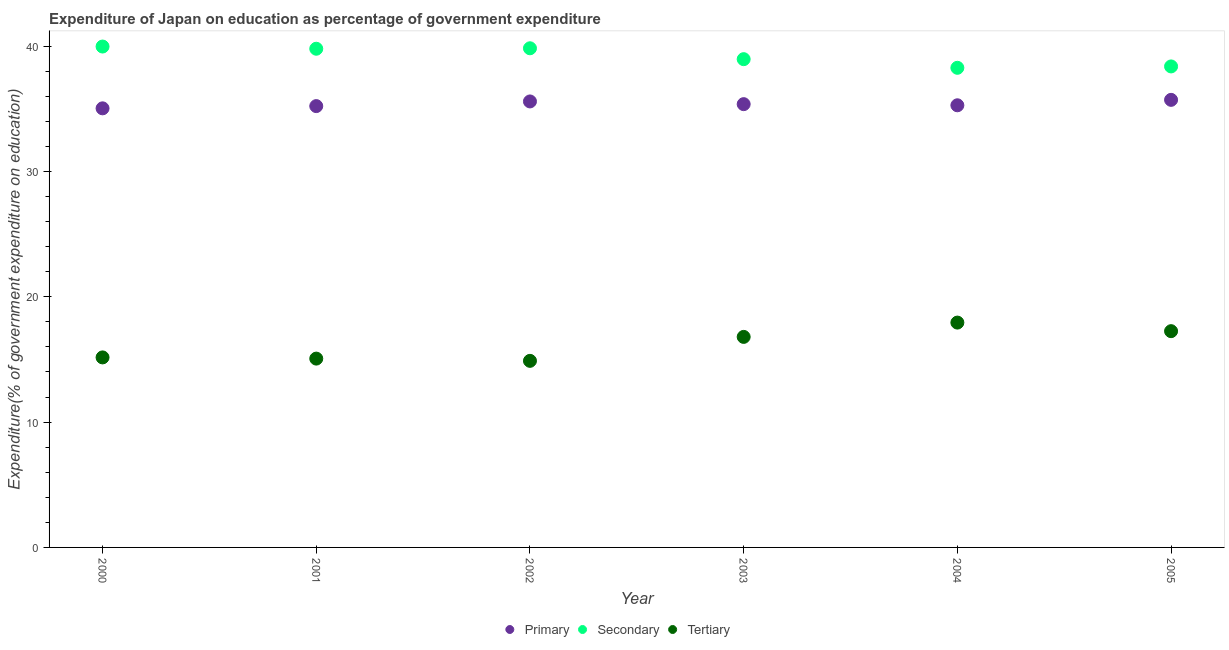What is the expenditure on primary education in 2000?
Ensure brevity in your answer.  35.03. Across all years, what is the maximum expenditure on secondary education?
Your response must be concise. 39.96. Across all years, what is the minimum expenditure on tertiary education?
Provide a short and direct response. 14.88. In which year was the expenditure on tertiary education maximum?
Offer a very short reply. 2004. What is the total expenditure on primary education in the graph?
Make the answer very short. 212.16. What is the difference between the expenditure on primary education in 2000 and that in 2001?
Offer a terse response. -0.18. What is the difference between the expenditure on primary education in 2003 and the expenditure on tertiary education in 2001?
Your answer should be very brief. 20.3. What is the average expenditure on secondary education per year?
Keep it short and to the point. 39.19. In the year 2000, what is the difference between the expenditure on secondary education and expenditure on primary education?
Offer a terse response. 4.93. In how many years, is the expenditure on tertiary education greater than 38 %?
Offer a terse response. 0. What is the ratio of the expenditure on primary education in 2002 to that in 2003?
Make the answer very short. 1.01. Is the expenditure on primary education in 2001 less than that in 2004?
Your answer should be compact. Yes. Is the difference between the expenditure on primary education in 2000 and 2002 greater than the difference between the expenditure on secondary education in 2000 and 2002?
Ensure brevity in your answer.  No. What is the difference between the highest and the second highest expenditure on primary education?
Give a very brief answer. 0.13. What is the difference between the highest and the lowest expenditure on tertiary education?
Provide a short and direct response. 3.05. Is it the case that in every year, the sum of the expenditure on primary education and expenditure on secondary education is greater than the expenditure on tertiary education?
Offer a very short reply. Yes. Does the expenditure on primary education monotonically increase over the years?
Your response must be concise. No. Is the expenditure on primary education strictly greater than the expenditure on secondary education over the years?
Your answer should be very brief. No. How many dotlines are there?
Give a very brief answer. 3. How many years are there in the graph?
Ensure brevity in your answer.  6. Are the values on the major ticks of Y-axis written in scientific E-notation?
Ensure brevity in your answer.  No. Does the graph contain any zero values?
Provide a short and direct response. No. Does the graph contain grids?
Your response must be concise. No. Where does the legend appear in the graph?
Ensure brevity in your answer.  Bottom center. What is the title of the graph?
Give a very brief answer. Expenditure of Japan on education as percentage of government expenditure. Does "Transport services" appear as one of the legend labels in the graph?
Provide a short and direct response. No. What is the label or title of the X-axis?
Provide a succinct answer. Year. What is the label or title of the Y-axis?
Provide a short and direct response. Expenditure(% of government expenditure on education). What is the Expenditure(% of government expenditure on education) in Primary in 2000?
Your response must be concise. 35.03. What is the Expenditure(% of government expenditure on education) in Secondary in 2000?
Make the answer very short. 39.96. What is the Expenditure(% of government expenditure on education) of Tertiary in 2000?
Keep it short and to the point. 15.16. What is the Expenditure(% of government expenditure on education) in Primary in 2001?
Provide a short and direct response. 35.21. What is the Expenditure(% of government expenditure on education) of Secondary in 2001?
Provide a succinct answer. 39.78. What is the Expenditure(% of government expenditure on education) of Tertiary in 2001?
Provide a short and direct response. 15.06. What is the Expenditure(% of government expenditure on education) in Primary in 2002?
Offer a terse response. 35.58. What is the Expenditure(% of government expenditure on education) of Secondary in 2002?
Make the answer very short. 39.82. What is the Expenditure(% of government expenditure on education) in Tertiary in 2002?
Give a very brief answer. 14.88. What is the Expenditure(% of government expenditure on education) of Primary in 2003?
Provide a succinct answer. 35.36. What is the Expenditure(% of government expenditure on education) of Secondary in 2003?
Provide a short and direct response. 38.95. What is the Expenditure(% of government expenditure on education) of Tertiary in 2003?
Offer a terse response. 16.8. What is the Expenditure(% of government expenditure on education) in Primary in 2004?
Ensure brevity in your answer.  35.27. What is the Expenditure(% of government expenditure on education) in Secondary in 2004?
Your answer should be compact. 38.26. What is the Expenditure(% of government expenditure on education) of Tertiary in 2004?
Offer a very short reply. 17.94. What is the Expenditure(% of government expenditure on education) in Primary in 2005?
Ensure brevity in your answer.  35.71. What is the Expenditure(% of government expenditure on education) in Secondary in 2005?
Provide a succinct answer. 38.37. What is the Expenditure(% of government expenditure on education) in Tertiary in 2005?
Provide a succinct answer. 17.25. Across all years, what is the maximum Expenditure(% of government expenditure on education) in Primary?
Your response must be concise. 35.71. Across all years, what is the maximum Expenditure(% of government expenditure on education) of Secondary?
Your response must be concise. 39.96. Across all years, what is the maximum Expenditure(% of government expenditure on education) in Tertiary?
Your answer should be very brief. 17.94. Across all years, what is the minimum Expenditure(% of government expenditure on education) in Primary?
Offer a terse response. 35.03. Across all years, what is the minimum Expenditure(% of government expenditure on education) in Secondary?
Give a very brief answer. 38.26. Across all years, what is the minimum Expenditure(% of government expenditure on education) of Tertiary?
Keep it short and to the point. 14.88. What is the total Expenditure(% of government expenditure on education) of Primary in the graph?
Offer a terse response. 212.16. What is the total Expenditure(% of government expenditure on education) in Secondary in the graph?
Provide a succinct answer. 235.15. What is the total Expenditure(% of government expenditure on education) of Tertiary in the graph?
Provide a short and direct response. 97.09. What is the difference between the Expenditure(% of government expenditure on education) in Primary in 2000 and that in 2001?
Your response must be concise. -0.18. What is the difference between the Expenditure(% of government expenditure on education) in Secondary in 2000 and that in 2001?
Provide a short and direct response. 0.18. What is the difference between the Expenditure(% of government expenditure on education) of Tertiary in 2000 and that in 2001?
Make the answer very short. 0.1. What is the difference between the Expenditure(% of government expenditure on education) of Primary in 2000 and that in 2002?
Provide a short and direct response. -0.55. What is the difference between the Expenditure(% of government expenditure on education) in Secondary in 2000 and that in 2002?
Your response must be concise. 0.14. What is the difference between the Expenditure(% of government expenditure on education) of Tertiary in 2000 and that in 2002?
Offer a very short reply. 0.27. What is the difference between the Expenditure(% of government expenditure on education) in Primary in 2000 and that in 2003?
Your answer should be very brief. -0.33. What is the difference between the Expenditure(% of government expenditure on education) in Tertiary in 2000 and that in 2003?
Offer a terse response. -1.64. What is the difference between the Expenditure(% of government expenditure on education) in Primary in 2000 and that in 2004?
Give a very brief answer. -0.24. What is the difference between the Expenditure(% of government expenditure on education) in Secondary in 2000 and that in 2004?
Your response must be concise. 1.7. What is the difference between the Expenditure(% of government expenditure on education) in Tertiary in 2000 and that in 2004?
Provide a succinct answer. -2.78. What is the difference between the Expenditure(% of government expenditure on education) in Primary in 2000 and that in 2005?
Provide a short and direct response. -0.68. What is the difference between the Expenditure(% of government expenditure on education) of Secondary in 2000 and that in 2005?
Offer a very short reply. 1.59. What is the difference between the Expenditure(% of government expenditure on education) in Tertiary in 2000 and that in 2005?
Offer a very short reply. -2.09. What is the difference between the Expenditure(% of government expenditure on education) in Primary in 2001 and that in 2002?
Give a very brief answer. -0.37. What is the difference between the Expenditure(% of government expenditure on education) of Secondary in 2001 and that in 2002?
Offer a very short reply. -0.04. What is the difference between the Expenditure(% of government expenditure on education) of Tertiary in 2001 and that in 2002?
Your answer should be very brief. 0.18. What is the difference between the Expenditure(% of government expenditure on education) of Primary in 2001 and that in 2003?
Your response must be concise. -0.16. What is the difference between the Expenditure(% of government expenditure on education) in Secondary in 2001 and that in 2003?
Offer a terse response. 0.83. What is the difference between the Expenditure(% of government expenditure on education) in Tertiary in 2001 and that in 2003?
Offer a terse response. -1.73. What is the difference between the Expenditure(% of government expenditure on education) in Primary in 2001 and that in 2004?
Ensure brevity in your answer.  -0.07. What is the difference between the Expenditure(% of government expenditure on education) of Secondary in 2001 and that in 2004?
Your answer should be compact. 1.52. What is the difference between the Expenditure(% of government expenditure on education) of Tertiary in 2001 and that in 2004?
Keep it short and to the point. -2.87. What is the difference between the Expenditure(% of government expenditure on education) of Primary in 2001 and that in 2005?
Your response must be concise. -0.5. What is the difference between the Expenditure(% of government expenditure on education) in Secondary in 2001 and that in 2005?
Offer a very short reply. 1.41. What is the difference between the Expenditure(% of government expenditure on education) of Tertiary in 2001 and that in 2005?
Ensure brevity in your answer.  -2.19. What is the difference between the Expenditure(% of government expenditure on education) of Primary in 2002 and that in 2003?
Ensure brevity in your answer.  0.22. What is the difference between the Expenditure(% of government expenditure on education) of Secondary in 2002 and that in 2003?
Offer a terse response. 0.87. What is the difference between the Expenditure(% of government expenditure on education) of Tertiary in 2002 and that in 2003?
Provide a succinct answer. -1.91. What is the difference between the Expenditure(% of government expenditure on education) in Primary in 2002 and that in 2004?
Ensure brevity in your answer.  0.31. What is the difference between the Expenditure(% of government expenditure on education) of Secondary in 2002 and that in 2004?
Your answer should be compact. 1.56. What is the difference between the Expenditure(% of government expenditure on education) in Tertiary in 2002 and that in 2004?
Make the answer very short. -3.05. What is the difference between the Expenditure(% of government expenditure on education) in Primary in 2002 and that in 2005?
Your answer should be compact. -0.13. What is the difference between the Expenditure(% of government expenditure on education) of Secondary in 2002 and that in 2005?
Offer a terse response. 1.45. What is the difference between the Expenditure(% of government expenditure on education) in Tertiary in 2002 and that in 2005?
Ensure brevity in your answer.  -2.37. What is the difference between the Expenditure(% of government expenditure on education) of Primary in 2003 and that in 2004?
Your response must be concise. 0.09. What is the difference between the Expenditure(% of government expenditure on education) of Secondary in 2003 and that in 2004?
Provide a short and direct response. 0.69. What is the difference between the Expenditure(% of government expenditure on education) of Tertiary in 2003 and that in 2004?
Offer a terse response. -1.14. What is the difference between the Expenditure(% of government expenditure on education) of Primary in 2003 and that in 2005?
Offer a very short reply. -0.34. What is the difference between the Expenditure(% of government expenditure on education) of Secondary in 2003 and that in 2005?
Your response must be concise. 0.58. What is the difference between the Expenditure(% of government expenditure on education) of Tertiary in 2003 and that in 2005?
Your answer should be very brief. -0.46. What is the difference between the Expenditure(% of government expenditure on education) of Primary in 2004 and that in 2005?
Offer a terse response. -0.43. What is the difference between the Expenditure(% of government expenditure on education) in Secondary in 2004 and that in 2005?
Provide a short and direct response. -0.11. What is the difference between the Expenditure(% of government expenditure on education) in Tertiary in 2004 and that in 2005?
Provide a succinct answer. 0.68. What is the difference between the Expenditure(% of government expenditure on education) of Primary in 2000 and the Expenditure(% of government expenditure on education) of Secondary in 2001?
Ensure brevity in your answer.  -4.75. What is the difference between the Expenditure(% of government expenditure on education) of Primary in 2000 and the Expenditure(% of government expenditure on education) of Tertiary in 2001?
Your response must be concise. 19.97. What is the difference between the Expenditure(% of government expenditure on education) in Secondary in 2000 and the Expenditure(% of government expenditure on education) in Tertiary in 2001?
Your answer should be compact. 24.9. What is the difference between the Expenditure(% of government expenditure on education) of Primary in 2000 and the Expenditure(% of government expenditure on education) of Secondary in 2002?
Provide a succinct answer. -4.79. What is the difference between the Expenditure(% of government expenditure on education) in Primary in 2000 and the Expenditure(% of government expenditure on education) in Tertiary in 2002?
Make the answer very short. 20.14. What is the difference between the Expenditure(% of government expenditure on education) of Secondary in 2000 and the Expenditure(% of government expenditure on education) of Tertiary in 2002?
Ensure brevity in your answer.  25.07. What is the difference between the Expenditure(% of government expenditure on education) of Primary in 2000 and the Expenditure(% of government expenditure on education) of Secondary in 2003?
Provide a short and direct response. -3.92. What is the difference between the Expenditure(% of government expenditure on education) in Primary in 2000 and the Expenditure(% of government expenditure on education) in Tertiary in 2003?
Provide a succinct answer. 18.23. What is the difference between the Expenditure(% of government expenditure on education) of Secondary in 2000 and the Expenditure(% of government expenditure on education) of Tertiary in 2003?
Give a very brief answer. 23.16. What is the difference between the Expenditure(% of government expenditure on education) in Primary in 2000 and the Expenditure(% of government expenditure on education) in Secondary in 2004?
Provide a succinct answer. -3.23. What is the difference between the Expenditure(% of government expenditure on education) of Primary in 2000 and the Expenditure(% of government expenditure on education) of Tertiary in 2004?
Offer a very short reply. 17.09. What is the difference between the Expenditure(% of government expenditure on education) of Secondary in 2000 and the Expenditure(% of government expenditure on education) of Tertiary in 2004?
Provide a succinct answer. 22.02. What is the difference between the Expenditure(% of government expenditure on education) in Primary in 2000 and the Expenditure(% of government expenditure on education) in Secondary in 2005?
Your answer should be very brief. -3.34. What is the difference between the Expenditure(% of government expenditure on education) of Primary in 2000 and the Expenditure(% of government expenditure on education) of Tertiary in 2005?
Offer a very short reply. 17.78. What is the difference between the Expenditure(% of government expenditure on education) of Secondary in 2000 and the Expenditure(% of government expenditure on education) of Tertiary in 2005?
Keep it short and to the point. 22.71. What is the difference between the Expenditure(% of government expenditure on education) in Primary in 2001 and the Expenditure(% of government expenditure on education) in Secondary in 2002?
Your answer should be compact. -4.61. What is the difference between the Expenditure(% of government expenditure on education) in Primary in 2001 and the Expenditure(% of government expenditure on education) in Tertiary in 2002?
Give a very brief answer. 20.32. What is the difference between the Expenditure(% of government expenditure on education) of Secondary in 2001 and the Expenditure(% of government expenditure on education) of Tertiary in 2002?
Provide a short and direct response. 24.9. What is the difference between the Expenditure(% of government expenditure on education) in Primary in 2001 and the Expenditure(% of government expenditure on education) in Secondary in 2003?
Give a very brief answer. -3.74. What is the difference between the Expenditure(% of government expenditure on education) of Primary in 2001 and the Expenditure(% of government expenditure on education) of Tertiary in 2003?
Keep it short and to the point. 18.41. What is the difference between the Expenditure(% of government expenditure on education) in Secondary in 2001 and the Expenditure(% of government expenditure on education) in Tertiary in 2003?
Make the answer very short. 22.99. What is the difference between the Expenditure(% of government expenditure on education) in Primary in 2001 and the Expenditure(% of government expenditure on education) in Secondary in 2004?
Your answer should be compact. -3.05. What is the difference between the Expenditure(% of government expenditure on education) in Primary in 2001 and the Expenditure(% of government expenditure on education) in Tertiary in 2004?
Offer a very short reply. 17.27. What is the difference between the Expenditure(% of government expenditure on education) of Secondary in 2001 and the Expenditure(% of government expenditure on education) of Tertiary in 2004?
Your response must be concise. 21.85. What is the difference between the Expenditure(% of government expenditure on education) in Primary in 2001 and the Expenditure(% of government expenditure on education) in Secondary in 2005?
Offer a terse response. -3.16. What is the difference between the Expenditure(% of government expenditure on education) in Primary in 2001 and the Expenditure(% of government expenditure on education) in Tertiary in 2005?
Provide a short and direct response. 17.96. What is the difference between the Expenditure(% of government expenditure on education) of Secondary in 2001 and the Expenditure(% of government expenditure on education) of Tertiary in 2005?
Offer a very short reply. 22.53. What is the difference between the Expenditure(% of government expenditure on education) in Primary in 2002 and the Expenditure(% of government expenditure on education) in Secondary in 2003?
Keep it short and to the point. -3.37. What is the difference between the Expenditure(% of government expenditure on education) in Primary in 2002 and the Expenditure(% of government expenditure on education) in Tertiary in 2003?
Provide a short and direct response. 18.78. What is the difference between the Expenditure(% of government expenditure on education) of Secondary in 2002 and the Expenditure(% of government expenditure on education) of Tertiary in 2003?
Your answer should be very brief. 23.03. What is the difference between the Expenditure(% of government expenditure on education) in Primary in 2002 and the Expenditure(% of government expenditure on education) in Secondary in 2004?
Your answer should be very brief. -2.68. What is the difference between the Expenditure(% of government expenditure on education) in Primary in 2002 and the Expenditure(% of government expenditure on education) in Tertiary in 2004?
Provide a short and direct response. 17.64. What is the difference between the Expenditure(% of government expenditure on education) of Secondary in 2002 and the Expenditure(% of government expenditure on education) of Tertiary in 2004?
Your answer should be compact. 21.88. What is the difference between the Expenditure(% of government expenditure on education) in Primary in 2002 and the Expenditure(% of government expenditure on education) in Secondary in 2005?
Make the answer very short. -2.79. What is the difference between the Expenditure(% of government expenditure on education) in Primary in 2002 and the Expenditure(% of government expenditure on education) in Tertiary in 2005?
Your answer should be very brief. 18.33. What is the difference between the Expenditure(% of government expenditure on education) of Secondary in 2002 and the Expenditure(% of government expenditure on education) of Tertiary in 2005?
Your response must be concise. 22.57. What is the difference between the Expenditure(% of government expenditure on education) of Primary in 2003 and the Expenditure(% of government expenditure on education) of Secondary in 2004?
Make the answer very short. -2.9. What is the difference between the Expenditure(% of government expenditure on education) in Primary in 2003 and the Expenditure(% of government expenditure on education) in Tertiary in 2004?
Your answer should be very brief. 17.43. What is the difference between the Expenditure(% of government expenditure on education) of Secondary in 2003 and the Expenditure(% of government expenditure on education) of Tertiary in 2004?
Your answer should be compact. 21.02. What is the difference between the Expenditure(% of government expenditure on education) in Primary in 2003 and the Expenditure(% of government expenditure on education) in Secondary in 2005?
Provide a short and direct response. -3.01. What is the difference between the Expenditure(% of government expenditure on education) of Primary in 2003 and the Expenditure(% of government expenditure on education) of Tertiary in 2005?
Provide a short and direct response. 18.11. What is the difference between the Expenditure(% of government expenditure on education) of Secondary in 2003 and the Expenditure(% of government expenditure on education) of Tertiary in 2005?
Your response must be concise. 21.7. What is the difference between the Expenditure(% of government expenditure on education) in Primary in 2004 and the Expenditure(% of government expenditure on education) in Secondary in 2005?
Give a very brief answer. -3.1. What is the difference between the Expenditure(% of government expenditure on education) in Primary in 2004 and the Expenditure(% of government expenditure on education) in Tertiary in 2005?
Your response must be concise. 18.02. What is the difference between the Expenditure(% of government expenditure on education) in Secondary in 2004 and the Expenditure(% of government expenditure on education) in Tertiary in 2005?
Offer a terse response. 21.01. What is the average Expenditure(% of government expenditure on education) in Primary per year?
Your answer should be very brief. 35.36. What is the average Expenditure(% of government expenditure on education) in Secondary per year?
Your answer should be compact. 39.19. What is the average Expenditure(% of government expenditure on education) of Tertiary per year?
Your response must be concise. 16.18. In the year 2000, what is the difference between the Expenditure(% of government expenditure on education) in Primary and Expenditure(% of government expenditure on education) in Secondary?
Your answer should be compact. -4.93. In the year 2000, what is the difference between the Expenditure(% of government expenditure on education) of Primary and Expenditure(% of government expenditure on education) of Tertiary?
Your answer should be very brief. 19.87. In the year 2000, what is the difference between the Expenditure(% of government expenditure on education) of Secondary and Expenditure(% of government expenditure on education) of Tertiary?
Ensure brevity in your answer.  24.8. In the year 2001, what is the difference between the Expenditure(% of government expenditure on education) of Primary and Expenditure(% of government expenditure on education) of Secondary?
Offer a terse response. -4.58. In the year 2001, what is the difference between the Expenditure(% of government expenditure on education) in Primary and Expenditure(% of government expenditure on education) in Tertiary?
Offer a terse response. 20.14. In the year 2001, what is the difference between the Expenditure(% of government expenditure on education) of Secondary and Expenditure(% of government expenditure on education) of Tertiary?
Provide a succinct answer. 24.72. In the year 2002, what is the difference between the Expenditure(% of government expenditure on education) in Primary and Expenditure(% of government expenditure on education) in Secondary?
Your response must be concise. -4.24. In the year 2002, what is the difference between the Expenditure(% of government expenditure on education) of Primary and Expenditure(% of government expenditure on education) of Tertiary?
Offer a very short reply. 20.7. In the year 2002, what is the difference between the Expenditure(% of government expenditure on education) of Secondary and Expenditure(% of government expenditure on education) of Tertiary?
Provide a succinct answer. 24.94. In the year 2003, what is the difference between the Expenditure(% of government expenditure on education) of Primary and Expenditure(% of government expenditure on education) of Secondary?
Make the answer very short. -3.59. In the year 2003, what is the difference between the Expenditure(% of government expenditure on education) in Primary and Expenditure(% of government expenditure on education) in Tertiary?
Give a very brief answer. 18.57. In the year 2003, what is the difference between the Expenditure(% of government expenditure on education) of Secondary and Expenditure(% of government expenditure on education) of Tertiary?
Keep it short and to the point. 22.16. In the year 2004, what is the difference between the Expenditure(% of government expenditure on education) in Primary and Expenditure(% of government expenditure on education) in Secondary?
Your answer should be compact. -2.99. In the year 2004, what is the difference between the Expenditure(% of government expenditure on education) in Primary and Expenditure(% of government expenditure on education) in Tertiary?
Provide a succinct answer. 17.34. In the year 2004, what is the difference between the Expenditure(% of government expenditure on education) of Secondary and Expenditure(% of government expenditure on education) of Tertiary?
Ensure brevity in your answer.  20.33. In the year 2005, what is the difference between the Expenditure(% of government expenditure on education) in Primary and Expenditure(% of government expenditure on education) in Secondary?
Your response must be concise. -2.67. In the year 2005, what is the difference between the Expenditure(% of government expenditure on education) in Primary and Expenditure(% of government expenditure on education) in Tertiary?
Ensure brevity in your answer.  18.45. In the year 2005, what is the difference between the Expenditure(% of government expenditure on education) in Secondary and Expenditure(% of government expenditure on education) in Tertiary?
Offer a very short reply. 21.12. What is the ratio of the Expenditure(% of government expenditure on education) in Tertiary in 2000 to that in 2001?
Your answer should be very brief. 1.01. What is the ratio of the Expenditure(% of government expenditure on education) of Primary in 2000 to that in 2002?
Provide a short and direct response. 0.98. What is the ratio of the Expenditure(% of government expenditure on education) in Secondary in 2000 to that in 2002?
Your response must be concise. 1. What is the ratio of the Expenditure(% of government expenditure on education) in Tertiary in 2000 to that in 2002?
Your response must be concise. 1.02. What is the ratio of the Expenditure(% of government expenditure on education) in Secondary in 2000 to that in 2003?
Provide a succinct answer. 1.03. What is the ratio of the Expenditure(% of government expenditure on education) of Tertiary in 2000 to that in 2003?
Ensure brevity in your answer.  0.9. What is the ratio of the Expenditure(% of government expenditure on education) of Secondary in 2000 to that in 2004?
Keep it short and to the point. 1.04. What is the ratio of the Expenditure(% of government expenditure on education) in Tertiary in 2000 to that in 2004?
Ensure brevity in your answer.  0.85. What is the ratio of the Expenditure(% of government expenditure on education) in Primary in 2000 to that in 2005?
Ensure brevity in your answer.  0.98. What is the ratio of the Expenditure(% of government expenditure on education) of Secondary in 2000 to that in 2005?
Keep it short and to the point. 1.04. What is the ratio of the Expenditure(% of government expenditure on education) of Tertiary in 2000 to that in 2005?
Provide a short and direct response. 0.88. What is the ratio of the Expenditure(% of government expenditure on education) of Primary in 2001 to that in 2002?
Your answer should be very brief. 0.99. What is the ratio of the Expenditure(% of government expenditure on education) of Secondary in 2001 to that in 2002?
Your answer should be very brief. 1. What is the ratio of the Expenditure(% of government expenditure on education) of Tertiary in 2001 to that in 2002?
Provide a short and direct response. 1.01. What is the ratio of the Expenditure(% of government expenditure on education) in Secondary in 2001 to that in 2003?
Provide a short and direct response. 1.02. What is the ratio of the Expenditure(% of government expenditure on education) in Tertiary in 2001 to that in 2003?
Make the answer very short. 0.9. What is the ratio of the Expenditure(% of government expenditure on education) in Primary in 2001 to that in 2004?
Keep it short and to the point. 1. What is the ratio of the Expenditure(% of government expenditure on education) in Secondary in 2001 to that in 2004?
Offer a very short reply. 1.04. What is the ratio of the Expenditure(% of government expenditure on education) in Tertiary in 2001 to that in 2004?
Your response must be concise. 0.84. What is the ratio of the Expenditure(% of government expenditure on education) of Primary in 2001 to that in 2005?
Give a very brief answer. 0.99. What is the ratio of the Expenditure(% of government expenditure on education) of Secondary in 2001 to that in 2005?
Give a very brief answer. 1.04. What is the ratio of the Expenditure(% of government expenditure on education) in Tertiary in 2001 to that in 2005?
Give a very brief answer. 0.87. What is the ratio of the Expenditure(% of government expenditure on education) in Secondary in 2002 to that in 2003?
Your answer should be compact. 1.02. What is the ratio of the Expenditure(% of government expenditure on education) in Tertiary in 2002 to that in 2003?
Your response must be concise. 0.89. What is the ratio of the Expenditure(% of government expenditure on education) of Primary in 2002 to that in 2004?
Keep it short and to the point. 1.01. What is the ratio of the Expenditure(% of government expenditure on education) in Secondary in 2002 to that in 2004?
Offer a terse response. 1.04. What is the ratio of the Expenditure(% of government expenditure on education) of Tertiary in 2002 to that in 2004?
Your answer should be very brief. 0.83. What is the ratio of the Expenditure(% of government expenditure on education) of Secondary in 2002 to that in 2005?
Your response must be concise. 1.04. What is the ratio of the Expenditure(% of government expenditure on education) of Tertiary in 2002 to that in 2005?
Offer a very short reply. 0.86. What is the ratio of the Expenditure(% of government expenditure on education) of Tertiary in 2003 to that in 2004?
Your answer should be very brief. 0.94. What is the ratio of the Expenditure(% of government expenditure on education) of Primary in 2003 to that in 2005?
Give a very brief answer. 0.99. What is the ratio of the Expenditure(% of government expenditure on education) of Secondary in 2003 to that in 2005?
Your answer should be compact. 1.02. What is the ratio of the Expenditure(% of government expenditure on education) of Tertiary in 2003 to that in 2005?
Your answer should be very brief. 0.97. What is the ratio of the Expenditure(% of government expenditure on education) in Primary in 2004 to that in 2005?
Provide a short and direct response. 0.99. What is the ratio of the Expenditure(% of government expenditure on education) of Secondary in 2004 to that in 2005?
Provide a short and direct response. 1. What is the ratio of the Expenditure(% of government expenditure on education) of Tertiary in 2004 to that in 2005?
Ensure brevity in your answer.  1.04. What is the difference between the highest and the second highest Expenditure(% of government expenditure on education) of Primary?
Make the answer very short. 0.13. What is the difference between the highest and the second highest Expenditure(% of government expenditure on education) of Secondary?
Make the answer very short. 0.14. What is the difference between the highest and the second highest Expenditure(% of government expenditure on education) of Tertiary?
Your answer should be very brief. 0.68. What is the difference between the highest and the lowest Expenditure(% of government expenditure on education) in Primary?
Your answer should be compact. 0.68. What is the difference between the highest and the lowest Expenditure(% of government expenditure on education) of Secondary?
Your answer should be compact. 1.7. What is the difference between the highest and the lowest Expenditure(% of government expenditure on education) in Tertiary?
Your answer should be very brief. 3.05. 